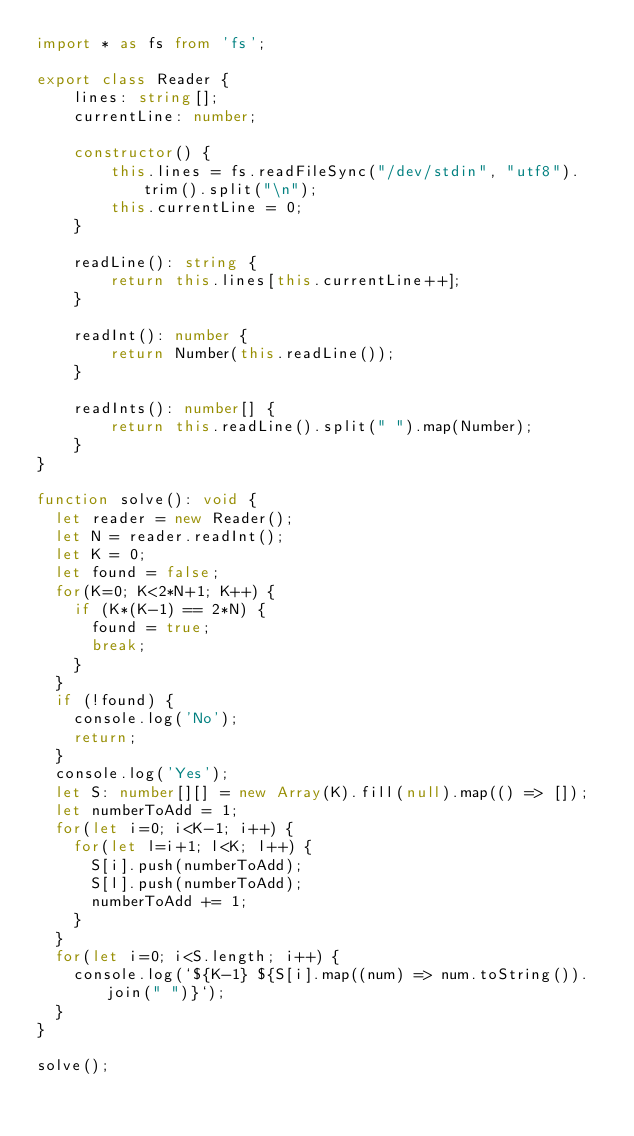<code> <loc_0><loc_0><loc_500><loc_500><_TypeScript_>import * as fs from 'fs';

export class Reader {
    lines: string[];
    currentLine: number;

    constructor() {
        this.lines = fs.readFileSync("/dev/stdin", "utf8").trim().split("\n");
        this.currentLine = 0;
    }

    readLine(): string {
        return this.lines[this.currentLine++];
    }

    readInt(): number {
        return Number(this.readLine());
    }

    readInts(): number[] {
        return this.readLine().split(" ").map(Number);
    }
}

function solve(): void {
	let reader = new Reader();
	let N = reader.readInt();
	let K = 0;
	let found = false;
	for(K=0; K<2*N+1; K++) {
		if (K*(K-1) == 2*N) {
			found = true;
			break;
		}
	}
	if (!found) {
		console.log('No');
		return;
	}
	console.log('Yes');
	let S: number[][] = new Array(K).fill(null).map(() => []);
	let numberToAdd = 1;
	for(let i=0; i<K-1; i++) {
		for(let l=i+1; l<K; l++) {
			S[i].push(numberToAdd);
			S[l].push(numberToAdd);
			numberToAdd += 1;
		}
	}
	for(let i=0; i<S.length; i++) {
		console.log(`${K-1} ${S[i].map((num) => num.toString()).join(" ")}`);
	}
}

solve();
</code> 